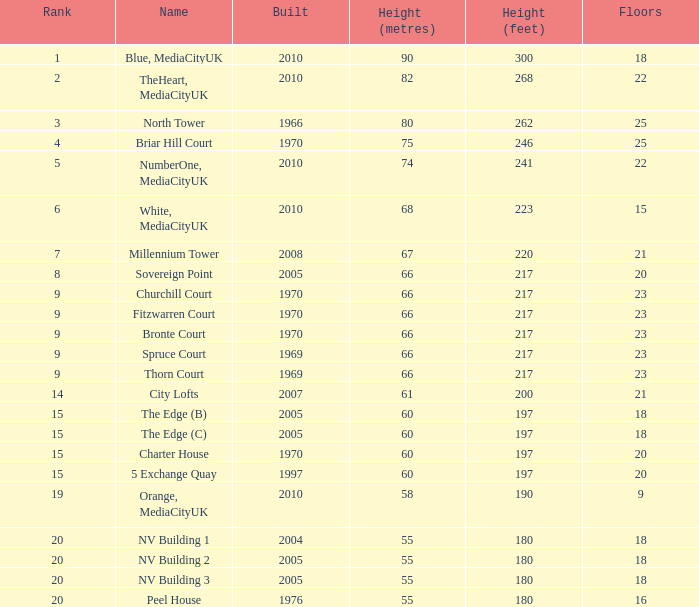What is the total number of Built, when Floors is less than 22, when Rank is less than 8, and when Name is White, Mediacityuk? 1.0. 